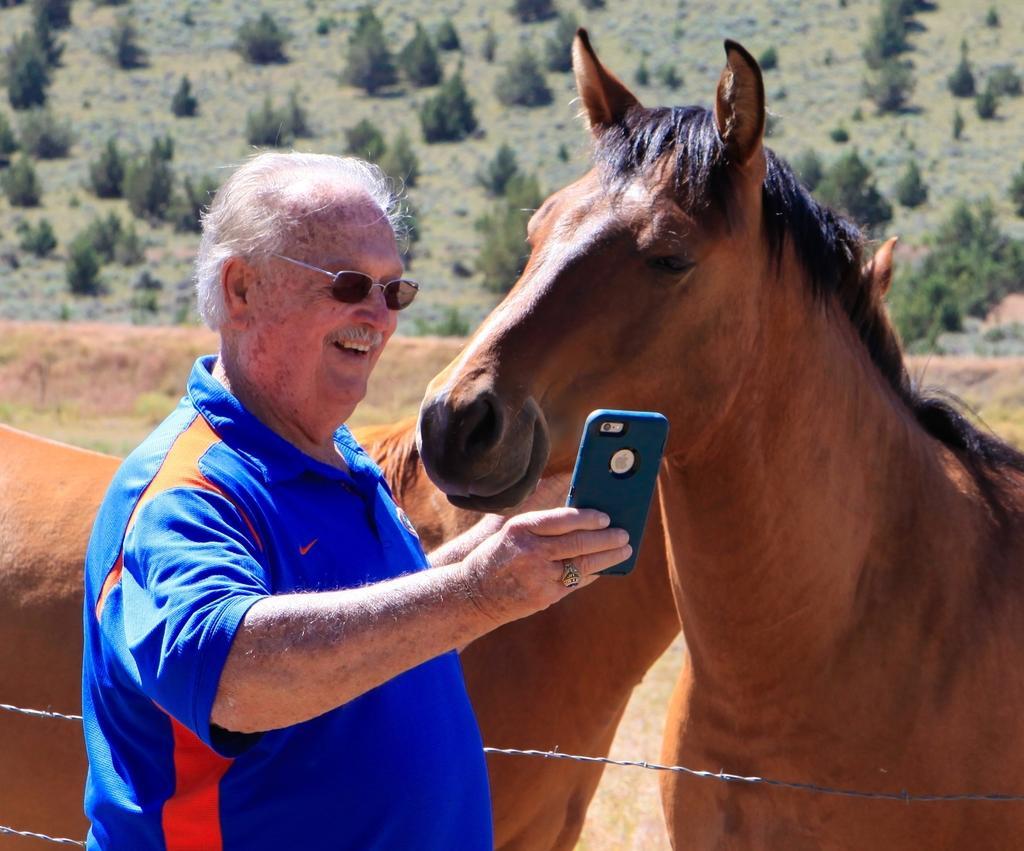How would you summarize this image in a sentence or two? This is a picture taken in the outdoors. The man in blue t shirt was holding a mobile. Behind the man there are two horses, trees and a path. 